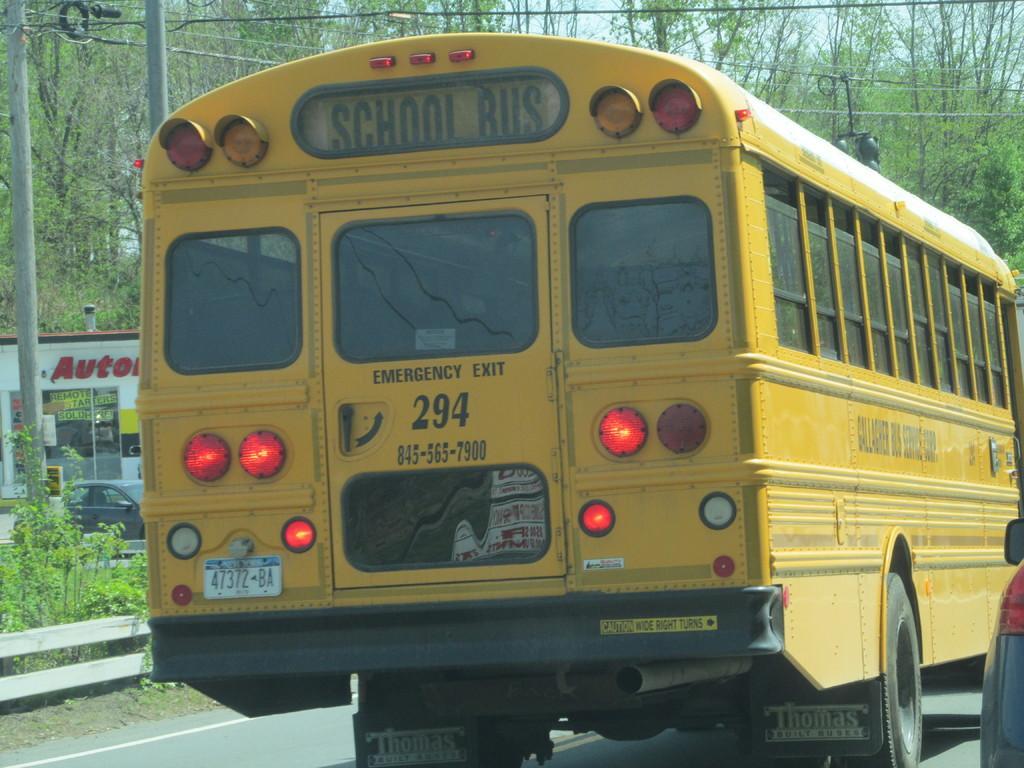Could you give a brief overview of what you see in this image? In this image in the center there is one bus, and on the right side there is one vehicle. And in the background there are some poles, trees, vehicles, building. And on the building there is some text, and at the bottom there is a walkway and on the left side of the image there is a fence. 